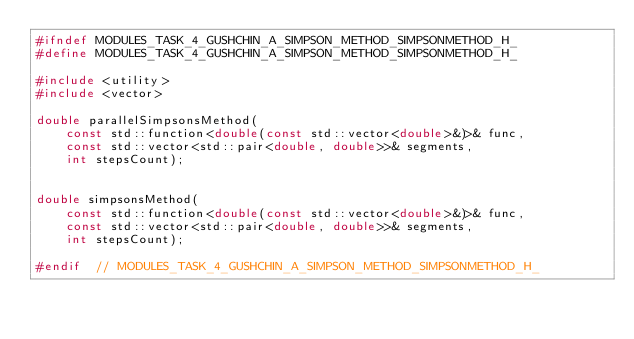Convert code to text. <code><loc_0><loc_0><loc_500><loc_500><_C_>#ifndef MODULES_TASK_4_GUSHCHIN_A_SIMPSON_METHOD_SIMPSONMETHOD_H_
#define MODULES_TASK_4_GUSHCHIN_A_SIMPSON_METHOD_SIMPSONMETHOD_H_

#include <utility>
#include <vector>

double parallelSimpsonsMethod(
    const std::function<double(const std::vector<double>&)>& func,
    const std::vector<std::pair<double, double>>& segments,
    int stepsCount);


double simpsonsMethod(
    const std::function<double(const std::vector<double>&)>& func,
    const std::vector<std::pair<double, double>>& segments,
    int stepsCount);

#endif  // MODULES_TASK_4_GUSHCHIN_A_SIMPSON_METHOD_SIMPSONMETHOD_H_
</code> 